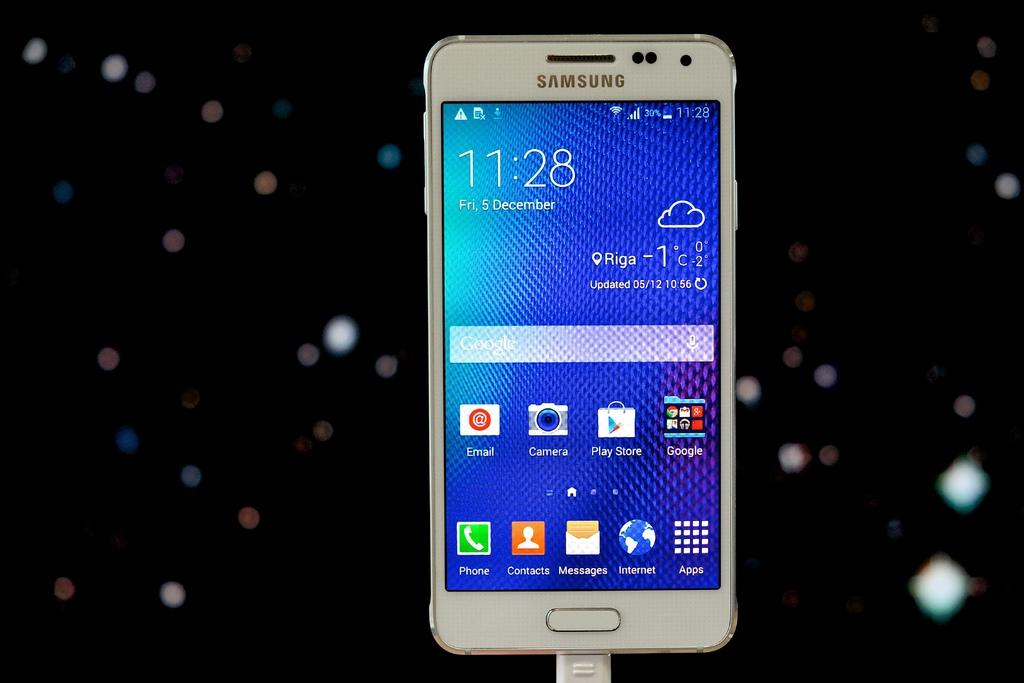Provide a one-sentence caption for the provided image. the time on a phone which says 11:28. 